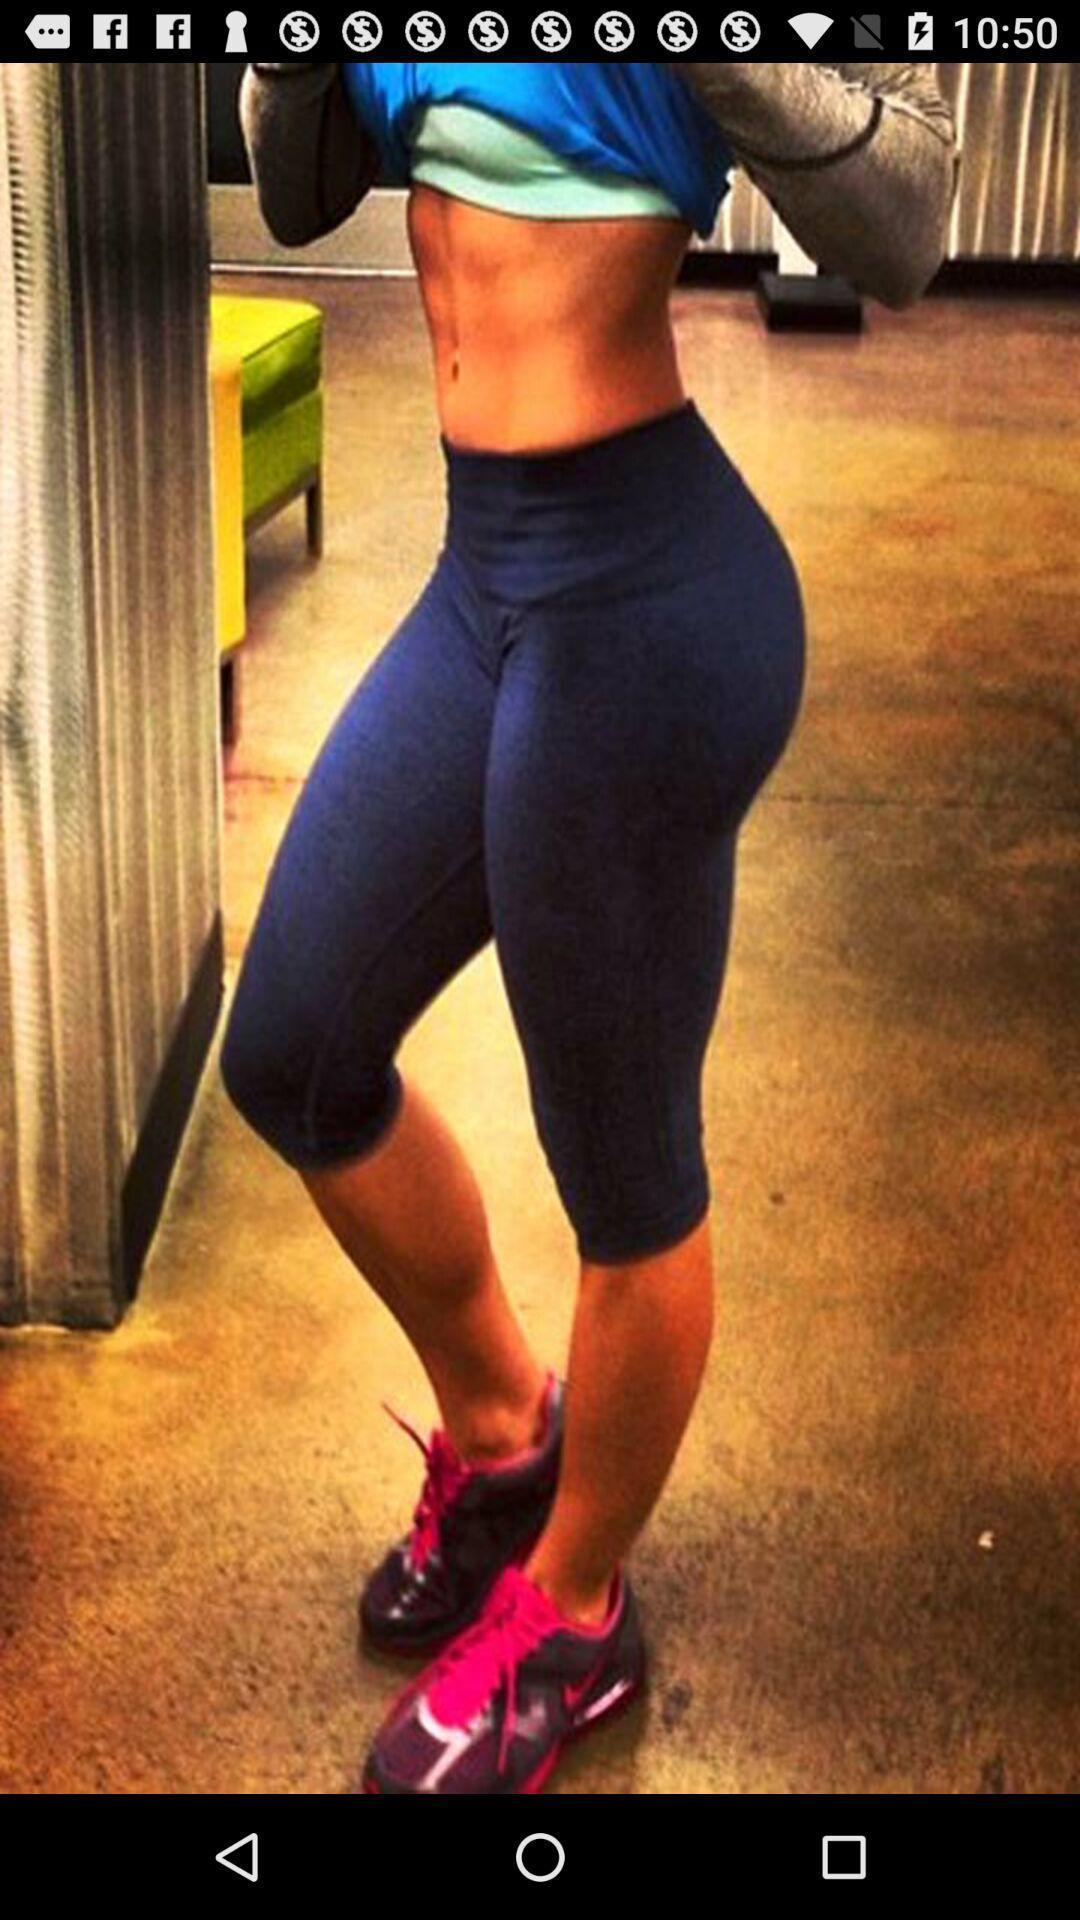Give me a summary of this screen capture. Page displaying an image of a girl. 